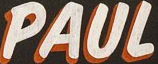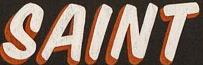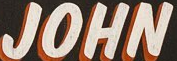What words are shown in these images in order, separated by a semicolon? PAUL; SAINT; JOHN 